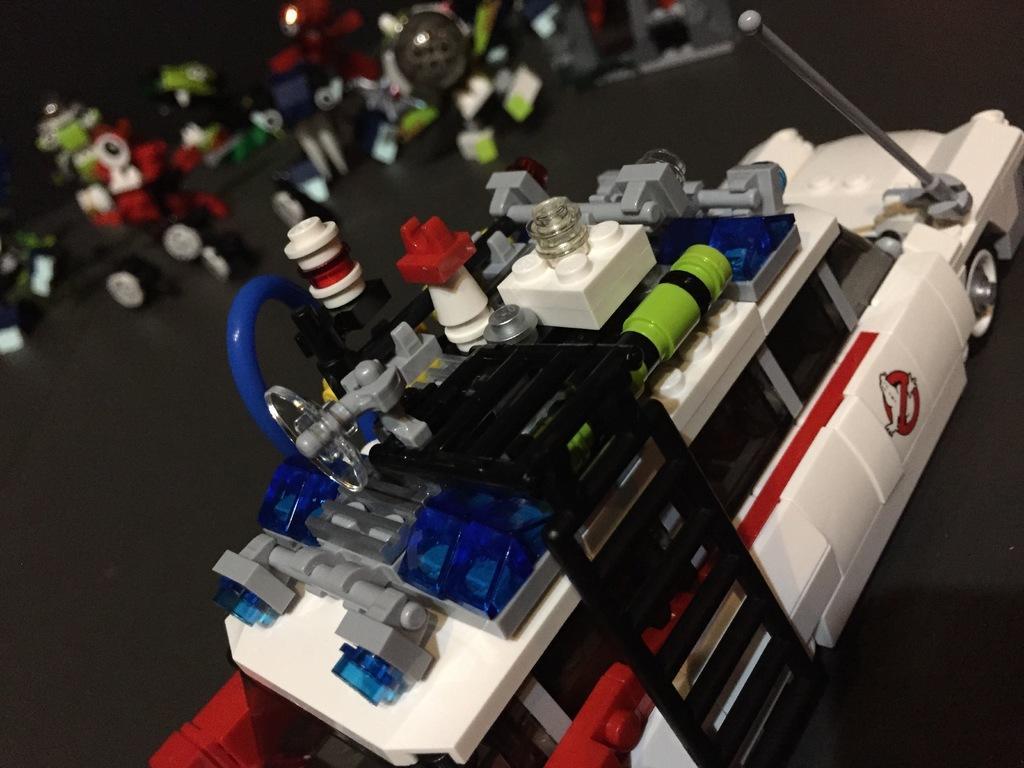How would you summarize this image in a sentence or two? In this picture there is a toy car on the table. In the background there are many toys.  